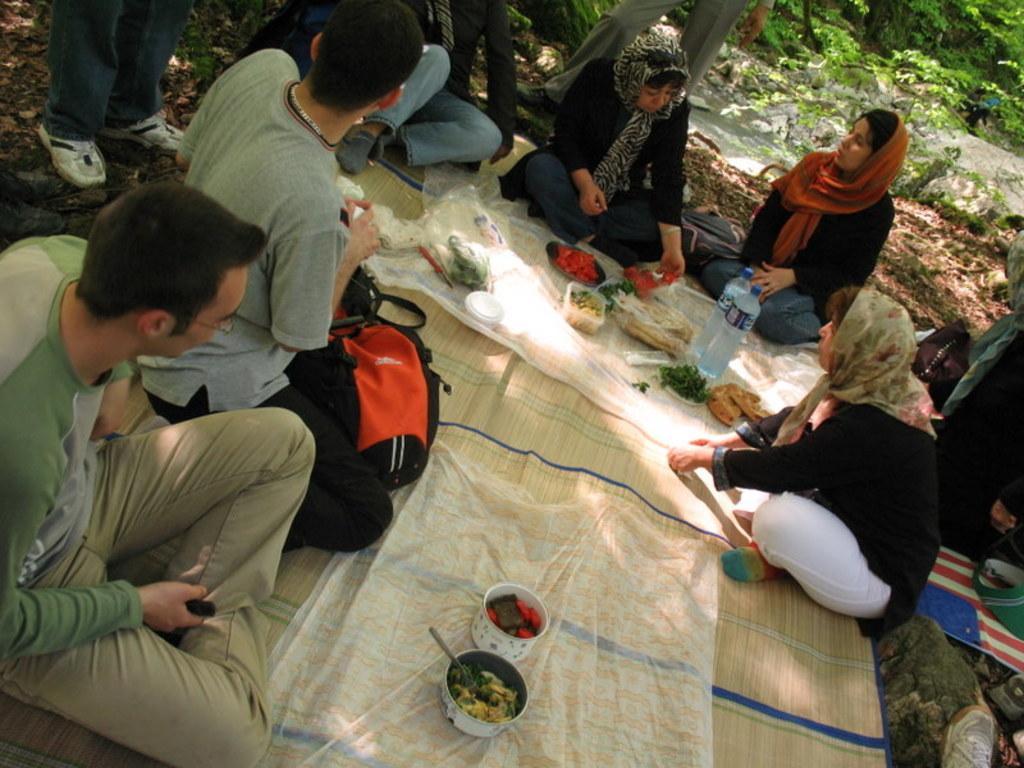Can you describe this image briefly? In this image we can see group of persons sitting on the ground. On the mat we can see bottles, food and bowls. In the background there is a water, plants and persons. 